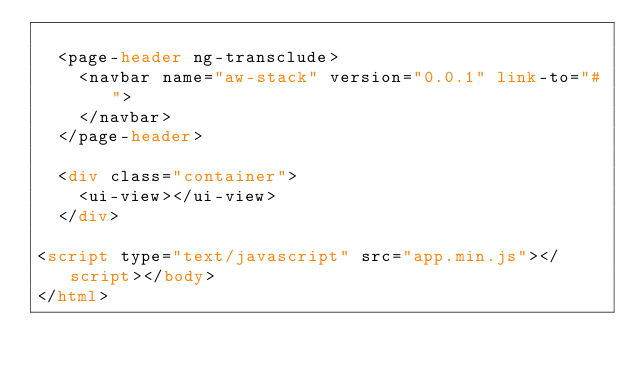Convert code to text. <code><loc_0><loc_0><loc_500><loc_500><_HTML_>
	<page-header ng-transclude>
		<navbar name="aw-stack" version="0.0.1" link-to="#">
		</navbar>
	</page-header>

	<div class="container">
		<ui-view></ui-view>
	</div>

<script type="text/javascript" src="app.min.js"></script></body>
</html>
</code> 